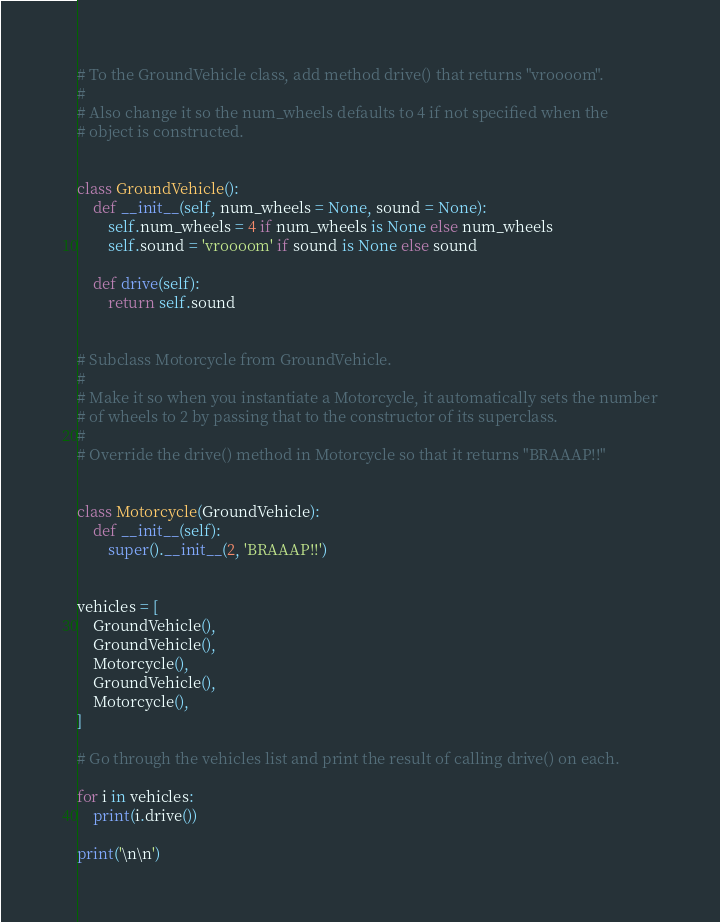<code> <loc_0><loc_0><loc_500><loc_500><_Python_># To the GroundVehicle class, add method drive() that returns "vroooom".
#
# Also change it so the num_wheels defaults to 4 if not specified when the
# object is constructed.


class GroundVehicle():
    def __init__(self, num_wheels = None, sound = None):
        self.num_wheels = 4 if num_wheels is None else num_wheels
        self.sound = 'vroooom' if sound is None else sound

    def drive(self):
        return self.sound


# Subclass Motorcycle from GroundVehicle.
#
# Make it so when you instantiate a Motorcycle, it automatically sets the number
# of wheels to 2 by passing that to the constructor of its superclass.
#
# Override the drive() method in Motorcycle so that it returns "BRAAAP!!"


class Motorcycle(GroundVehicle):
    def __init__(self):
        super().__init__(2, 'BRAAAP!!')


vehicles = [
    GroundVehicle(),
    GroundVehicle(),
    Motorcycle(),
    GroundVehicle(),
    Motorcycle(),
]

# Go through the vehicles list and print the result of calling drive() on each.

for i in vehicles:
    print(i.drive())

print('\n\n')
</code> 